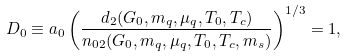<formula> <loc_0><loc_0><loc_500><loc_500>D _ { 0 } \equiv a _ { 0 } \left ( \frac { d _ { 2 } ( G _ { 0 } , m _ { q } , \mu _ { q } , T _ { 0 } , T _ { c } ) } { n _ { 0 2 } ( G _ { 0 } , m _ { q } , \mu _ { q } , T _ { 0 } , T _ { c } , m _ { s } ) } \right ) ^ { 1 / 3 } = 1 ,</formula> 